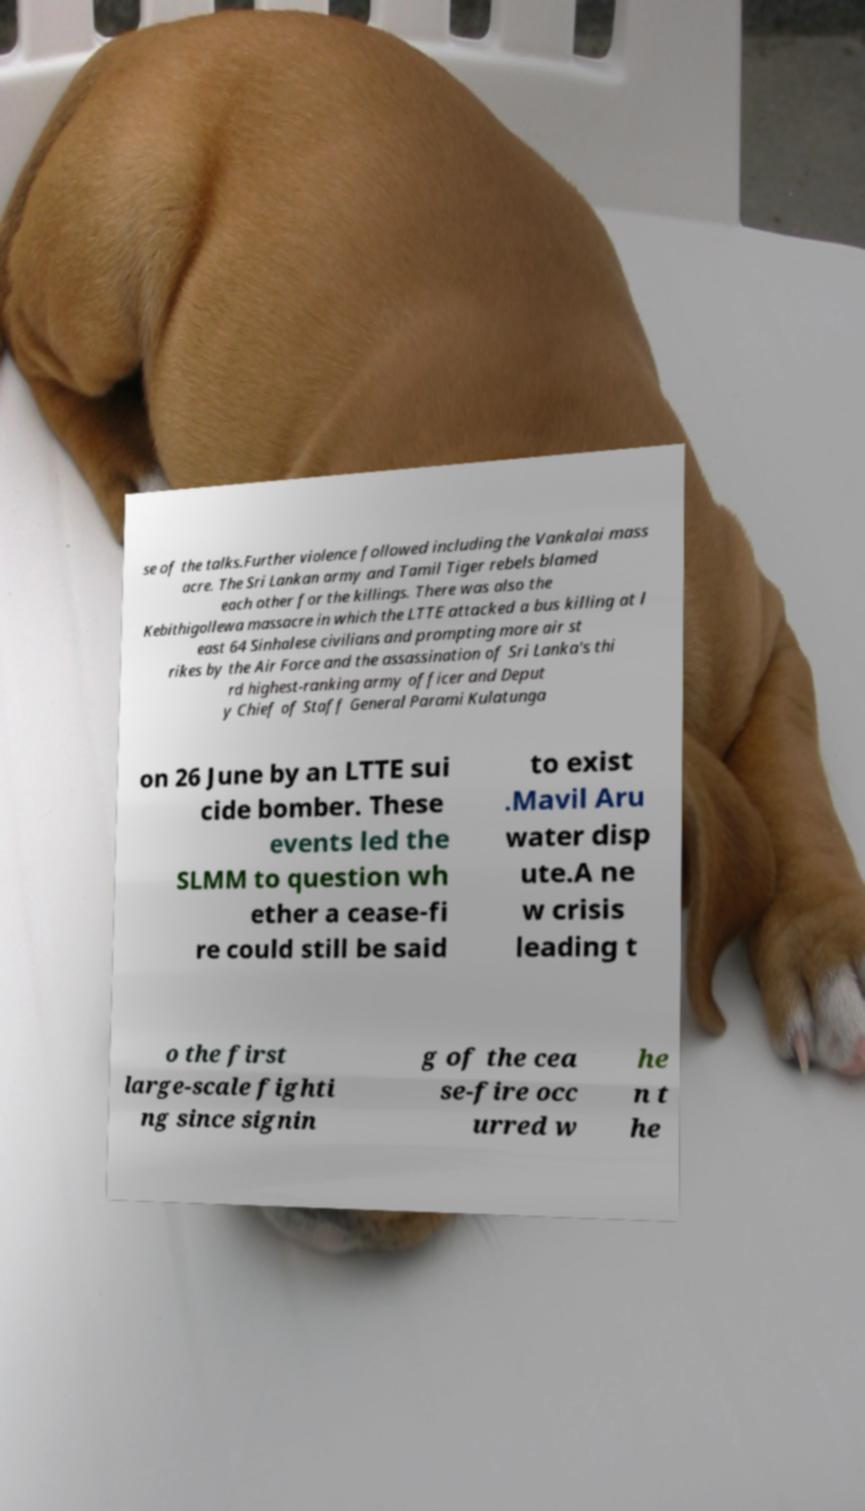Could you extract and type out the text from this image? se of the talks.Further violence followed including the Vankalai mass acre. The Sri Lankan army and Tamil Tiger rebels blamed each other for the killings. There was also the Kebithigollewa massacre in which the LTTE attacked a bus killing at l east 64 Sinhalese civilians and prompting more air st rikes by the Air Force and the assassination of Sri Lanka's thi rd highest-ranking army officer and Deput y Chief of Staff General Parami Kulatunga on 26 June by an LTTE sui cide bomber. These events led the SLMM to question wh ether a cease-fi re could still be said to exist .Mavil Aru water disp ute.A ne w crisis leading t o the first large-scale fighti ng since signin g of the cea se-fire occ urred w he n t he 